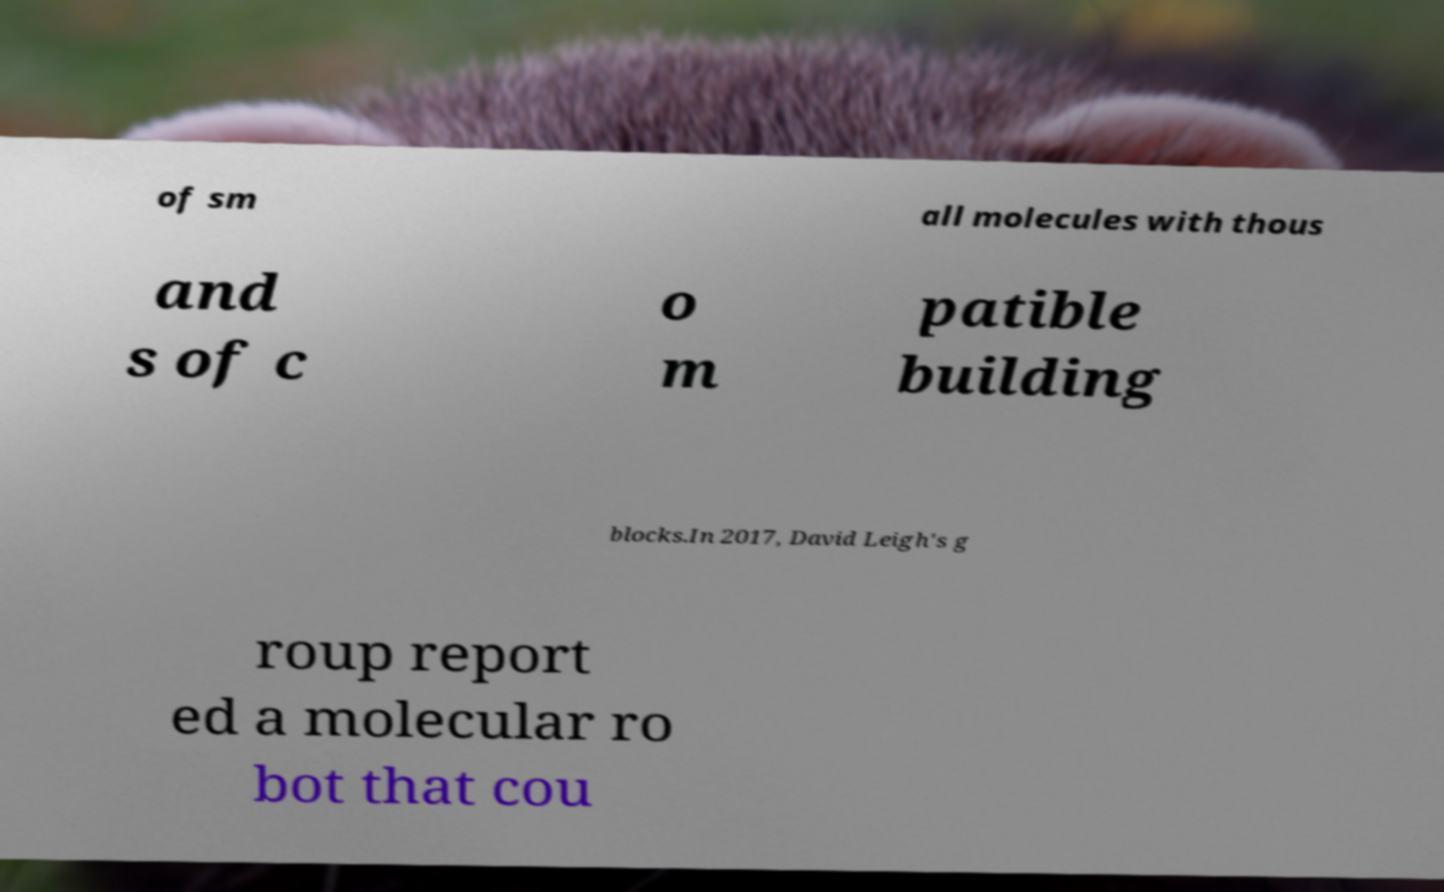There's text embedded in this image that I need extracted. Can you transcribe it verbatim? of sm all molecules with thous and s of c o m patible building blocks.In 2017, David Leigh's g roup report ed a molecular ro bot that cou 